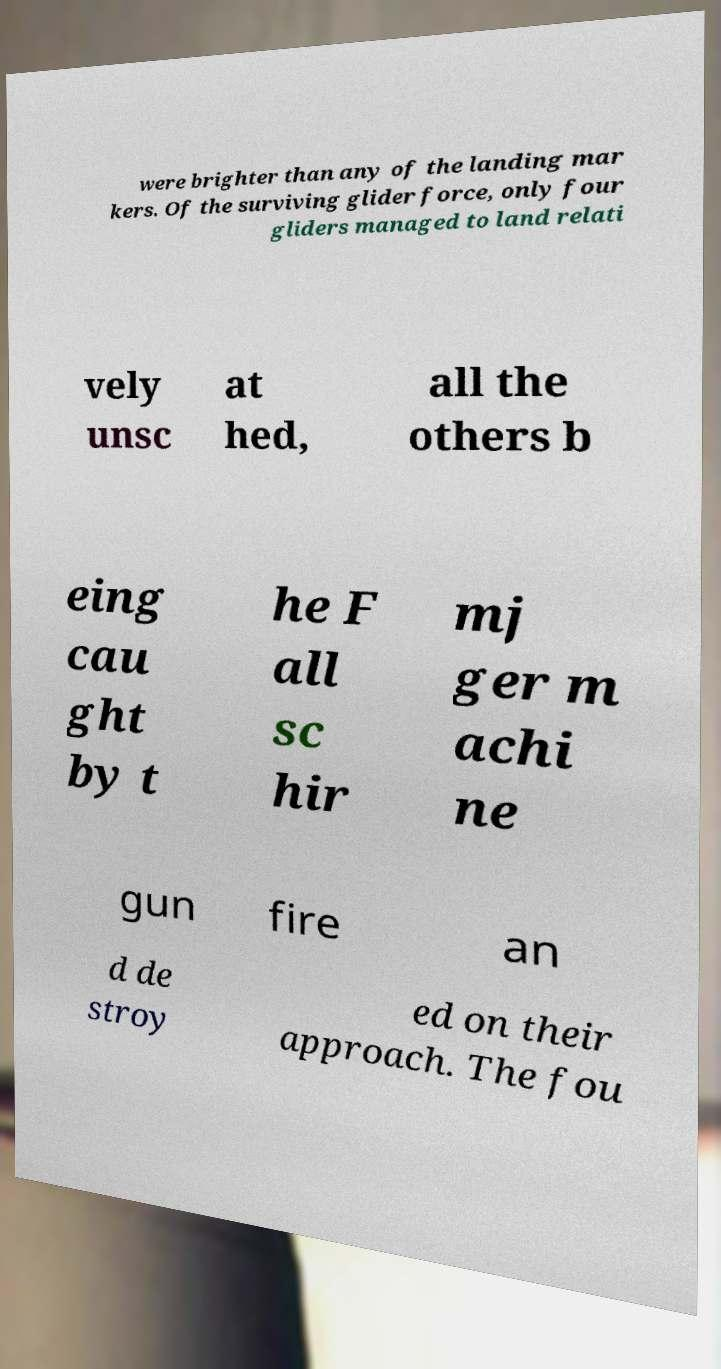Can you accurately transcribe the text from the provided image for me? were brighter than any of the landing mar kers. Of the surviving glider force, only four gliders managed to land relati vely unsc at hed, all the others b eing cau ght by t he F all sc hir mj ger m achi ne gun fire an d de stroy ed on their approach. The fou 